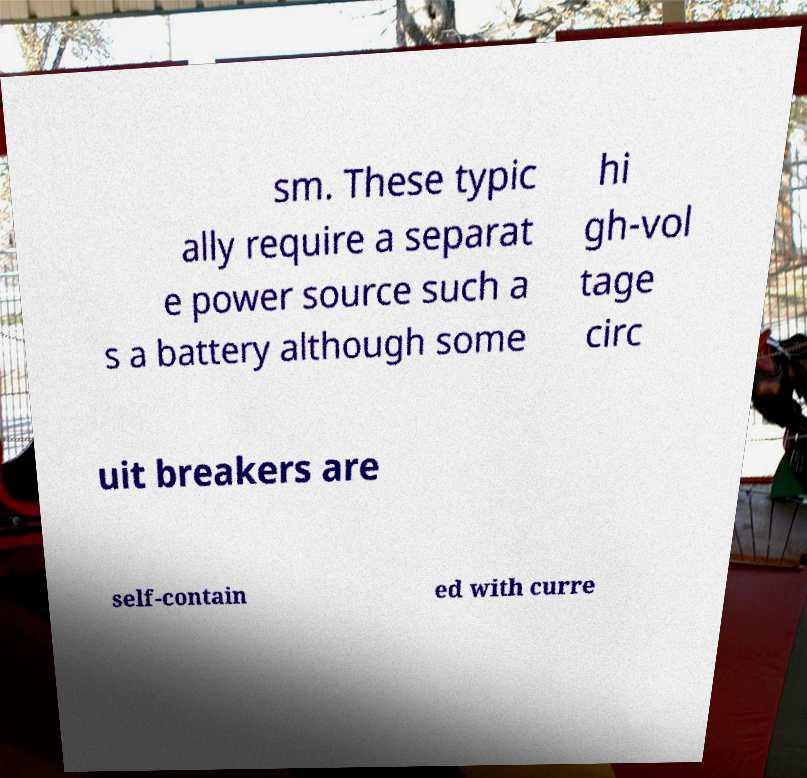For documentation purposes, I need the text within this image transcribed. Could you provide that? sm. These typic ally require a separat e power source such a s a battery although some hi gh-vol tage circ uit breakers are self-contain ed with curre 